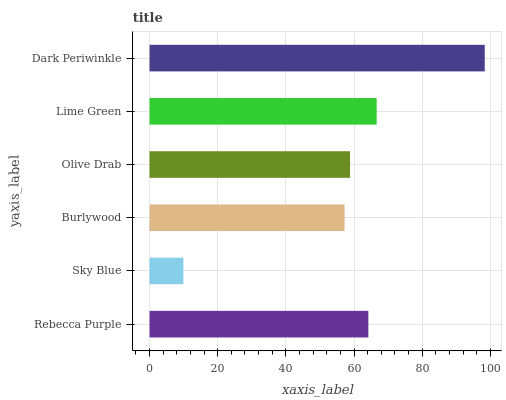Is Sky Blue the minimum?
Answer yes or no. Yes. Is Dark Periwinkle the maximum?
Answer yes or no. Yes. Is Burlywood the minimum?
Answer yes or no. No. Is Burlywood the maximum?
Answer yes or no. No. Is Burlywood greater than Sky Blue?
Answer yes or no. Yes. Is Sky Blue less than Burlywood?
Answer yes or no. Yes. Is Sky Blue greater than Burlywood?
Answer yes or no. No. Is Burlywood less than Sky Blue?
Answer yes or no. No. Is Rebecca Purple the high median?
Answer yes or no. Yes. Is Olive Drab the low median?
Answer yes or no. Yes. Is Dark Periwinkle the high median?
Answer yes or no. No. Is Rebecca Purple the low median?
Answer yes or no. No. 